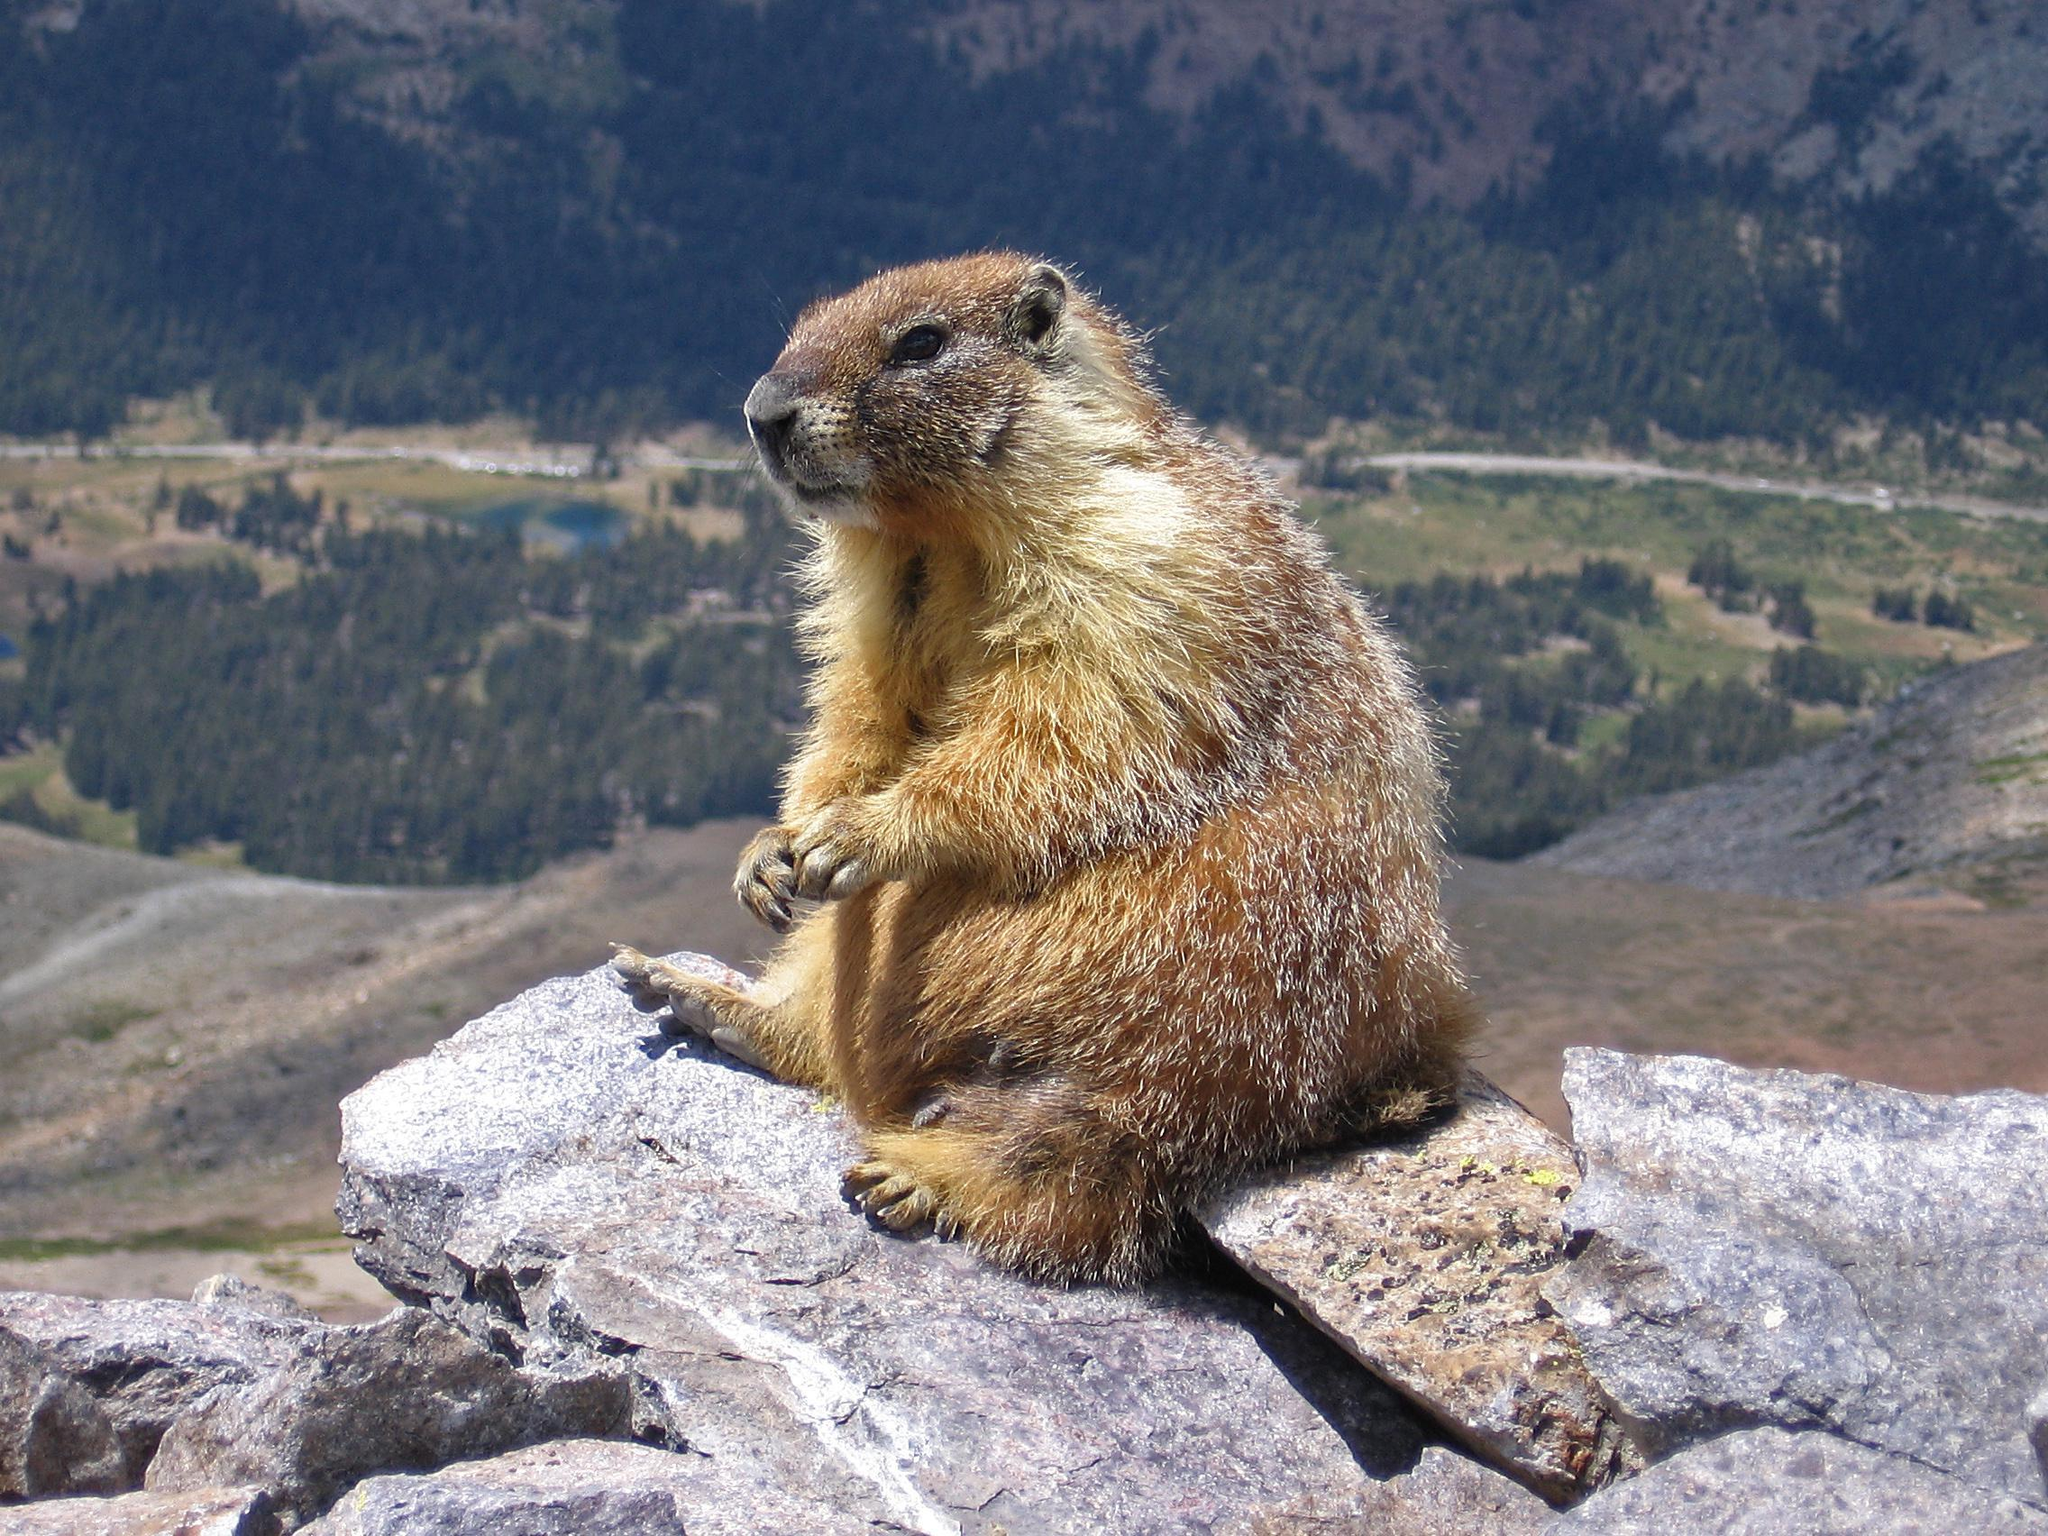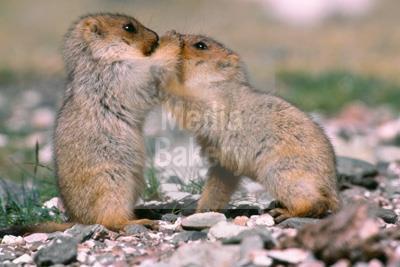The first image is the image on the left, the second image is the image on the right. Considering the images on both sides, is "Each image contains exactly one prairie dog type animal." valid? Answer yes or no. No. The first image is the image on the left, the second image is the image on the right. For the images shown, is this caption "There are no less than three animals" true? Answer yes or no. Yes. 